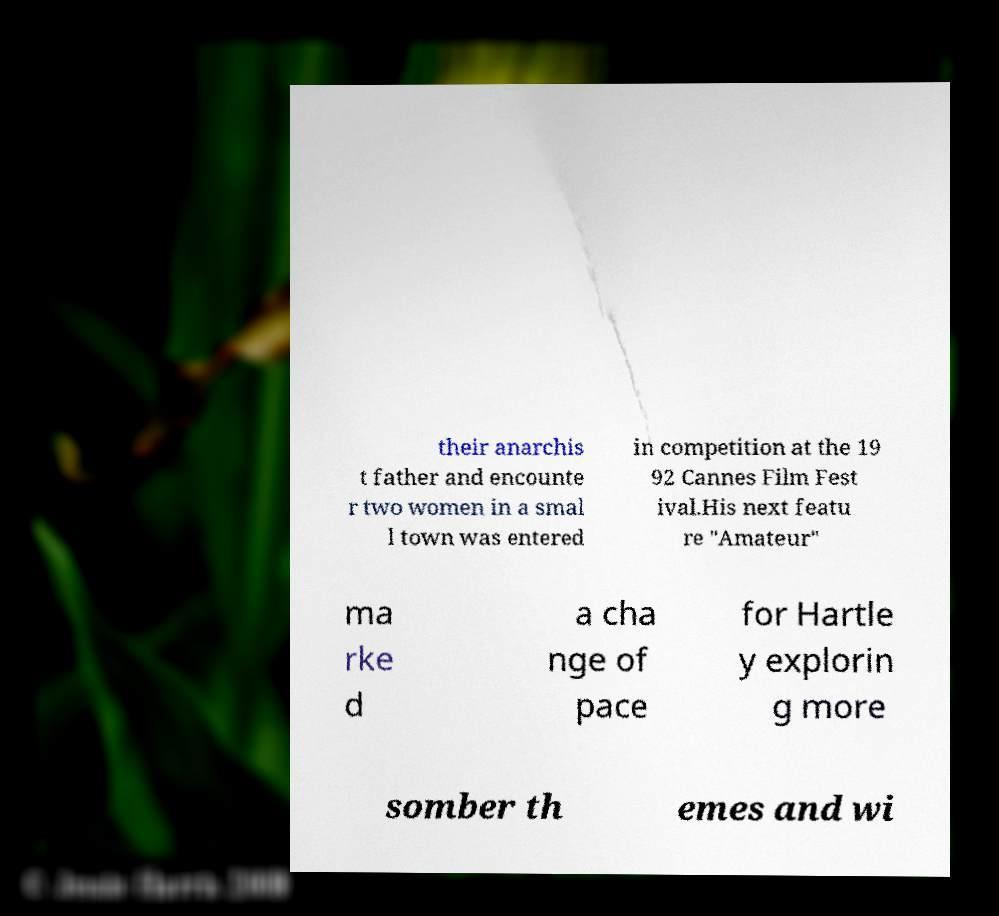Please identify and transcribe the text found in this image. their anarchis t father and encounte r two women in a smal l town was entered in competition at the 19 92 Cannes Film Fest ival.His next featu re "Amateur" ma rke d a cha nge of pace for Hartle y explorin g more somber th emes and wi 